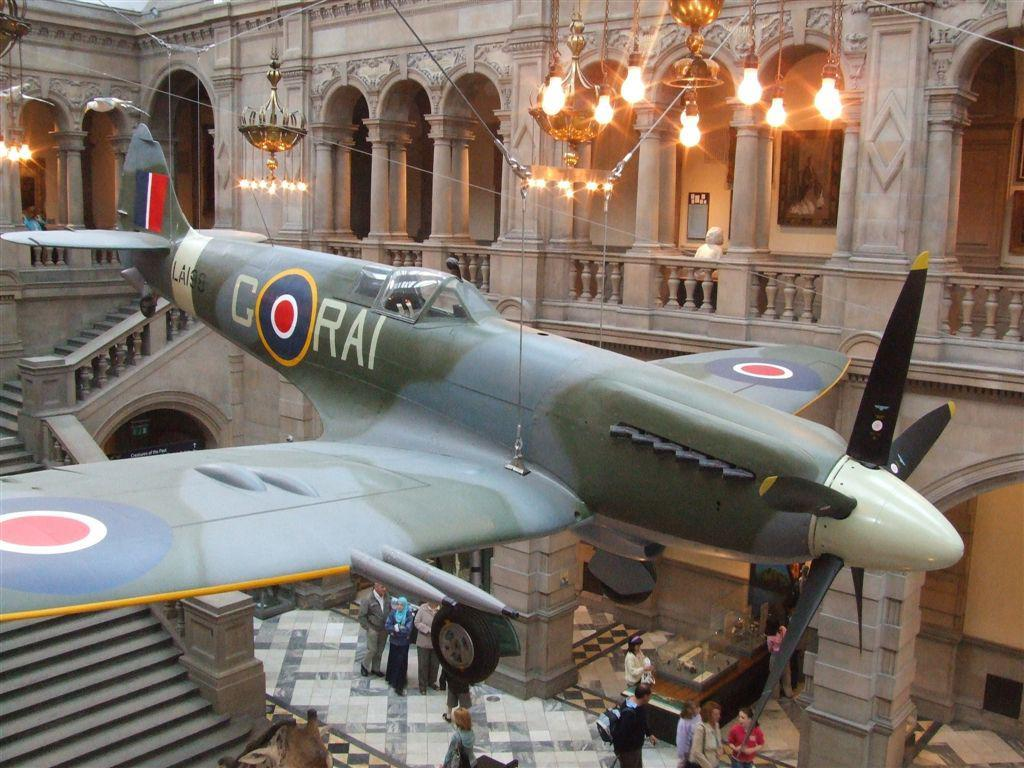What type of location is depicted in the image? The image shows the inner view of a building. What can be seen in the middle of the image? There is an aircraft in the middle of the image. Are there any people visible in the image? Yes, there are people visible at the bottom of the image. How many clouds can be seen in the image? There are no clouds visible in the image, as it shows the inner view of a building. What type of clothing are the girls wearing in the image? There are no girls present in the image. 